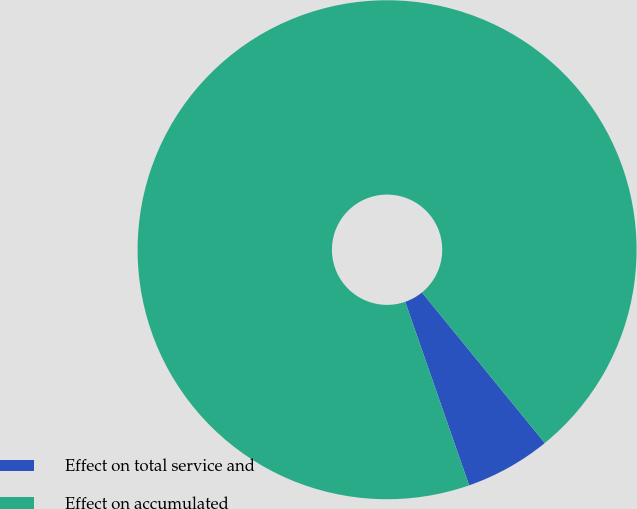Convert chart. <chart><loc_0><loc_0><loc_500><loc_500><pie_chart><fcel>Effect on total service and<fcel>Effect on accumulated<nl><fcel>5.56%<fcel>94.44%<nl></chart> 